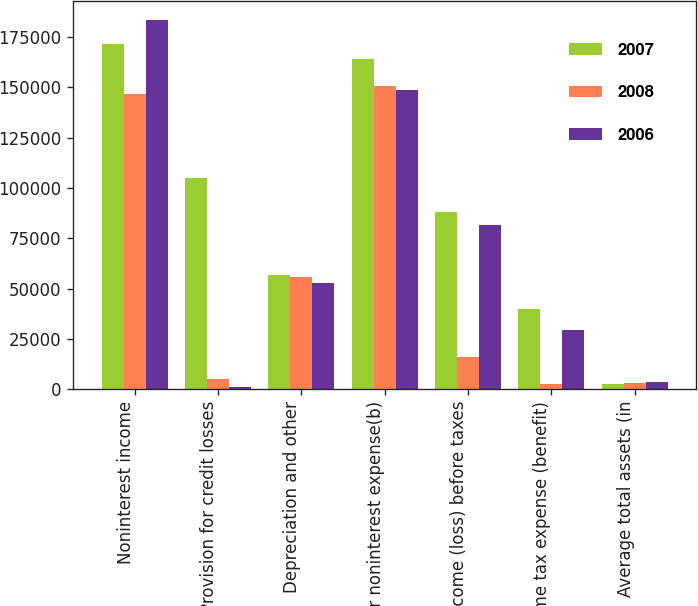Convert chart. <chart><loc_0><loc_0><loc_500><loc_500><stacked_bar_chart><ecel><fcel>Noninterest income<fcel>Provision for credit losses<fcel>Depreciation and other<fcel>Other noninterest expense(b)<fcel>Income (loss) before taxes<fcel>Income tax expense (benefit)<fcel>Average total assets (in<nl><fcel>2007<fcel>171774<fcel>104995<fcel>56666<fcel>164102<fcel>87938<fcel>39758<fcel>2660<nl><fcel>2008<fcel>146682<fcel>5302<fcel>55960<fcel>150591<fcel>15986<fcel>2593<fcel>2874<nl><fcel>2006<fcel>183677<fcel>953<fcel>52649<fcel>148432<fcel>81787<fcel>29611<fcel>3462<nl></chart> 